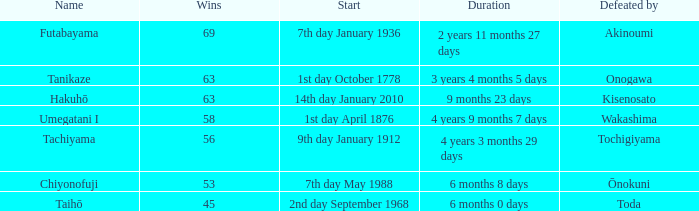What is the Duration for less than 53 consecutive wins? 6 months 0 days. 